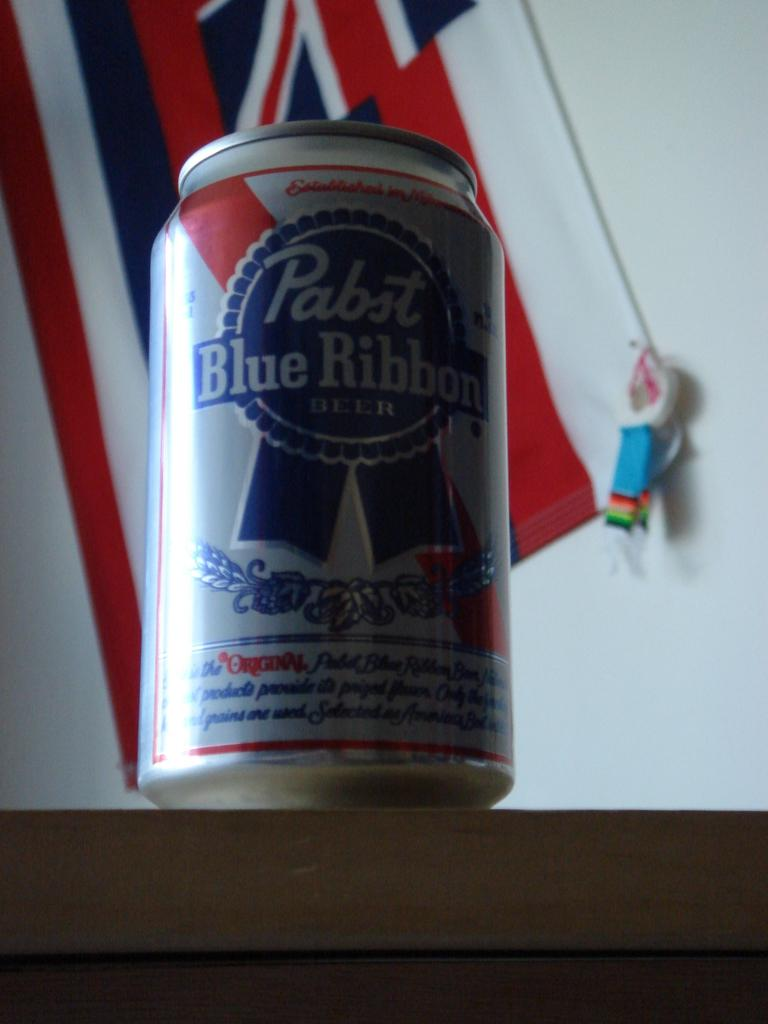<image>
Summarize the visual content of the image. A can of Pabst Blue Ribbon sits on a counter in front of a flag. 